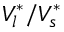Convert formula to latex. <formula><loc_0><loc_0><loc_500><loc_500>V _ { l } ^ { * } / V _ { s } ^ { * }</formula> 